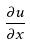<formula> <loc_0><loc_0><loc_500><loc_500>\frac { \partial u } { \partial x }</formula> 